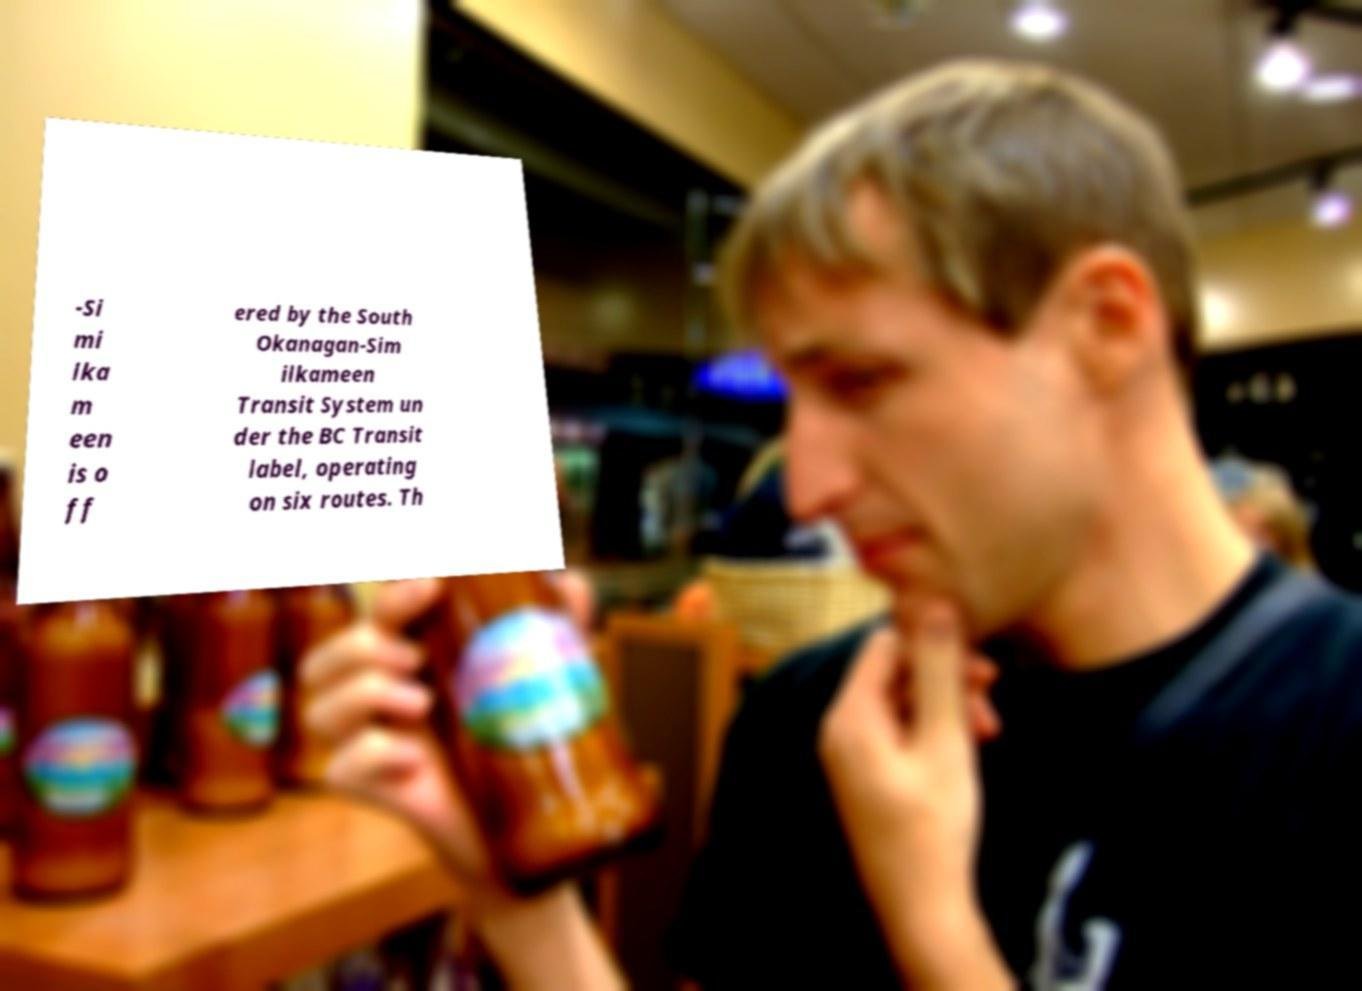Can you accurately transcribe the text from the provided image for me? -Si mi lka m een is o ff ered by the South Okanagan-Sim ilkameen Transit System un der the BC Transit label, operating on six routes. Th 